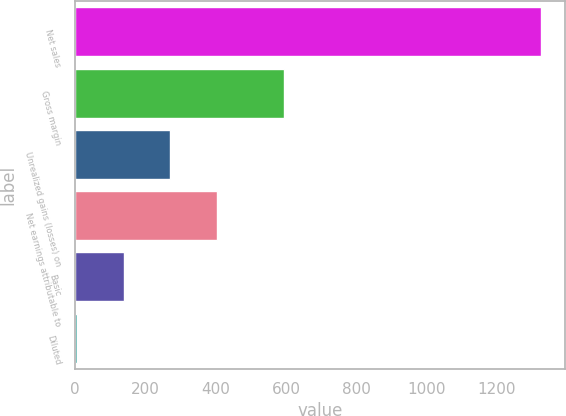Convert chart. <chart><loc_0><loc_0><loc_500><loc_500><bar_chart><fcel>Net sales<fcel>Gross margin<fcel>Unrealized gains (losses) on<fcel>Net earnings attributable to<fcel>Basic<fcel>Diluted<nl><fcel>1326.3<fcel>593.8<fcel>269.83<fcel>401.89<fcel>137.77<fcel>5.71<nl></chart> 